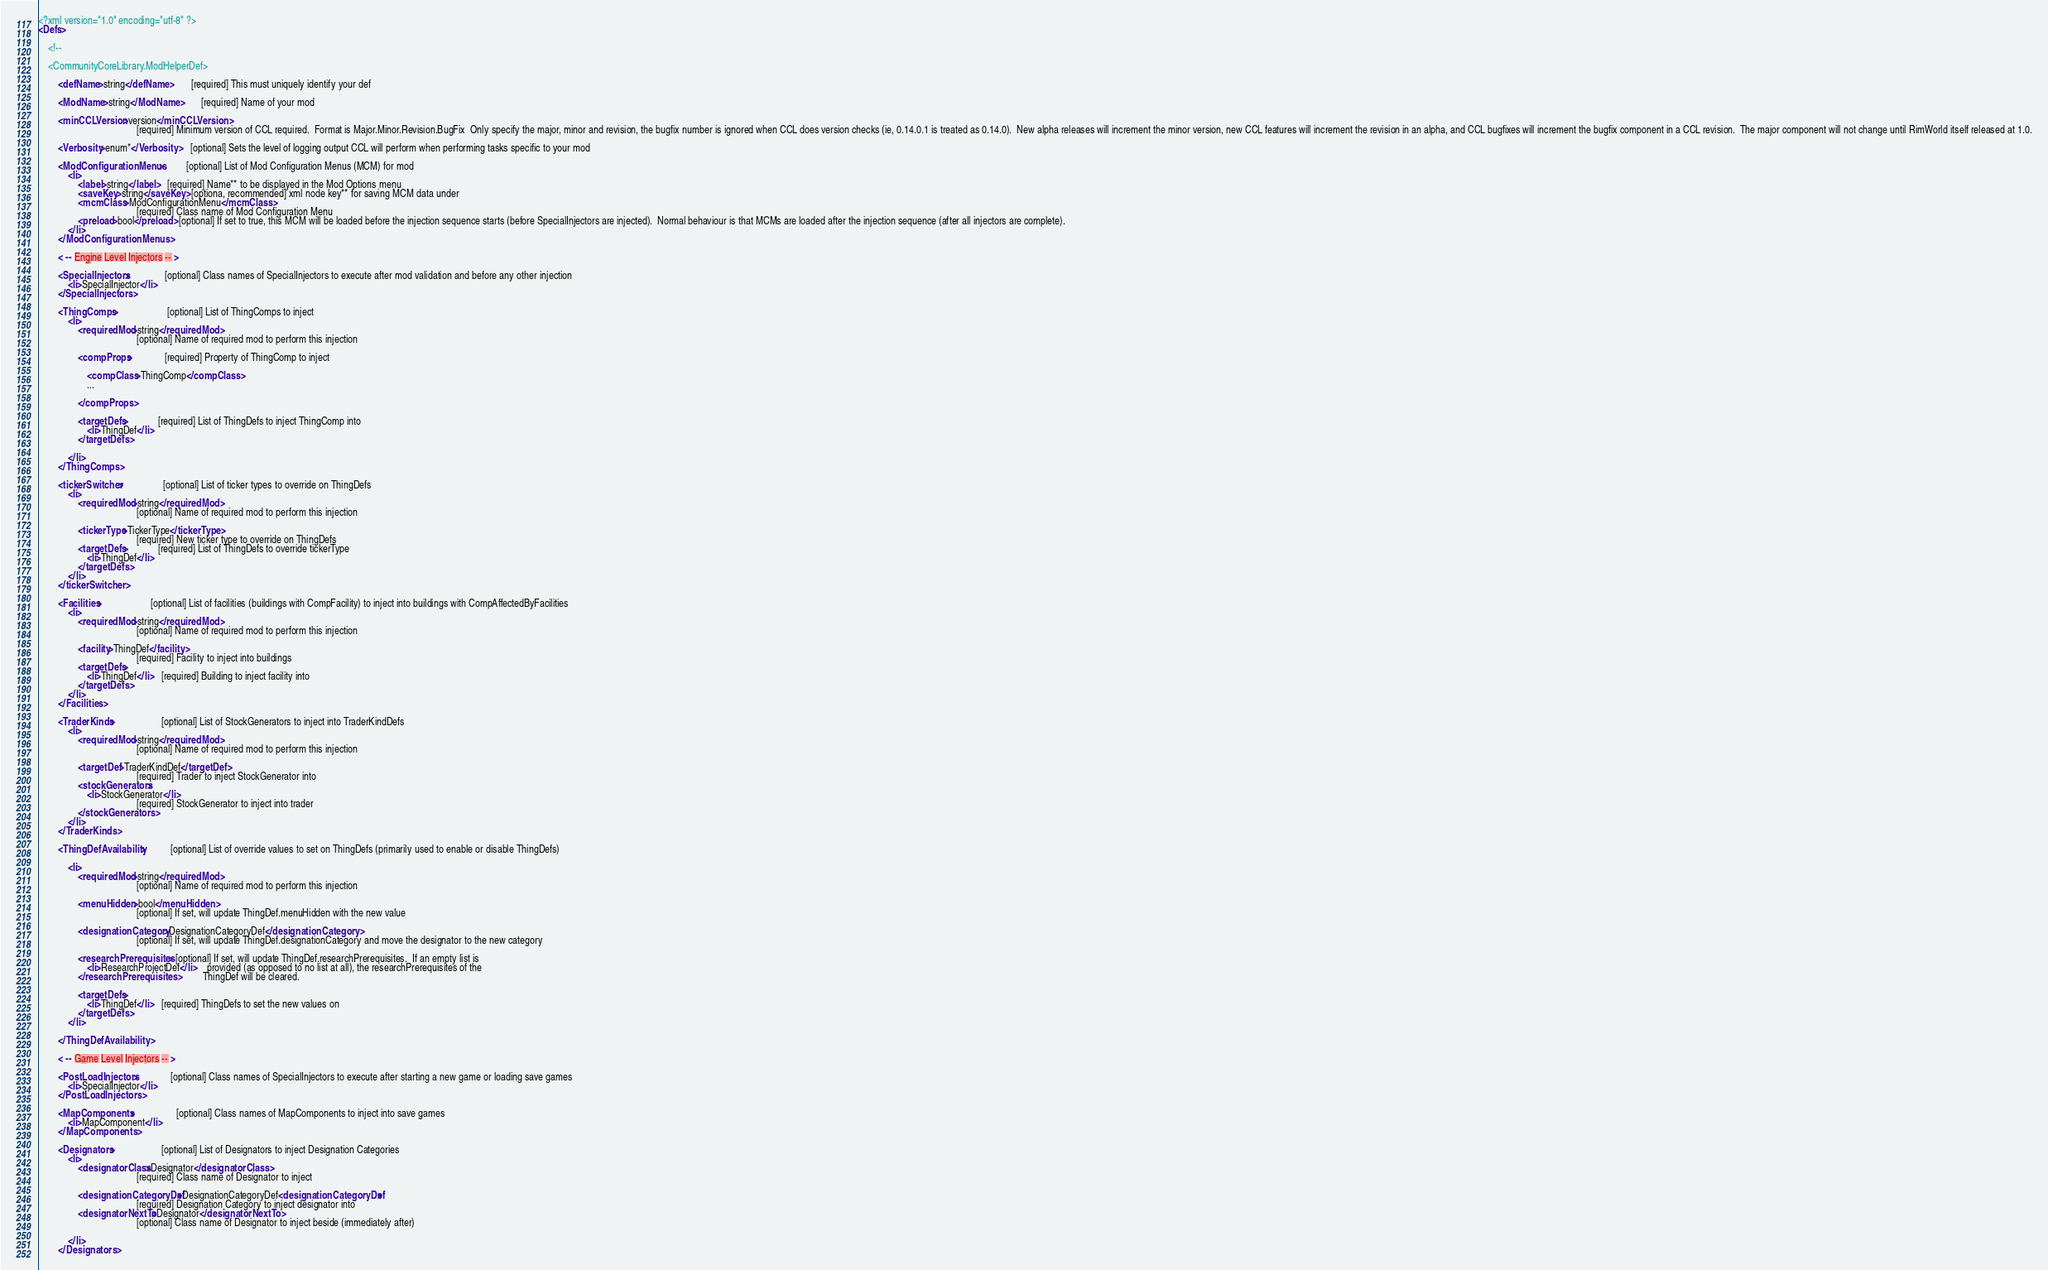<code> <loc_0><loc_0><loc_500><loc_500><_XML_><?xml version="1.0" encoding="utf-8" ?>
<Defs>

    <!--

    <CommunityCoreLibrary.ModHelperDef>

        <defName>string</defName>       [required] This must uniquely identify your def

        <ModName>string</ModName>       [required] Name of your mod

        <minCCLVersion>version</minCCLVersion>
                                        [required] Minimum version of CCL required.  Format is Major.Minor.Revision.BugFix  Only specify the major, minor and revision, the bugfix number is ignored when CCL does version checks (ie, 0.14.0.1 is treated as 0.14.0).  New alpha releases will increment the minor version, new CCL features will increment the revision in an alpha, and CCL bugfixes will increment the bugfix component in a CCL revision.  The major component will not change until RimWorld itself released at 1.0.

        <Verbosity>enum*</Verbosity>    [optional] Sets the level of logging output CCL will perform when performing tasks specific to your mod

        <ModConfigurationMenus>         [optional] List of Mod Configuration Menus (MCM) for mod
            <li>
                <label>string</label>   [required] Name** to be displayed in the Mod Options menu
                <saveKey>string</saveKey> [optiona, recommended] xml node key** for saving MCM data under
                <mcmClass>ModConfigurationMenu</mcmClass>
                                        [required] Class name of Mod Configuration Menu
                <preload>bool</preload> [optional] If set to true, this MCM will be loaded before the injection sequence starts (before SpecialInjectors are injected).  Normal behaviour is that MCMs are loaded after the injection sequence (after all injectors are complete).
            </li>
        </ModConfigurationMenus>

        < -- Engine Level Injectors -- >

        <SpecialInjectors>              [optional] Class names of SpecialInjectors to execute after mod validation and before any other injection
            <li>SpecialInjector</li>
        </SpecialInjectors>

        <ThingComps>                    [optional] List of ThingComps to inject
            <li>
                <requiredMod>string</requiredMod>
                                        [optional] Name of required mod to perform this injection

                <compProps>             [required] Property of ThingComp to inject

                    <compClass>ThingComp</compClass>
                    ...

                </compProps>

                <targetDefs>            [required] List of ThingDefs to inject ThingComp into
                    <li>ThingDef</li>
                </targetDefs>

            </li>
        </ThingComps>

        <tickerSwitcher>                [optional] List of ticker types to override on ThingDefs
            <li>
                <requiredMod>string</requiredMod>
                                        [optional] Name of required mod to perform this injection

                <tickerType>TickerType</tickerType>
                                        [required] New ticker type to override on ThingDefs
                <targetDefs>            [required] List of ThingDefs to override tickerType
                    <li>ThingDef</li>
                </targetDefs>
            </li>
        </tickerSwitcher>

        <Facilities>                    [optional] List of facilities (buildings with CompFacility) to inject into buildings with CompAffectedByFacilities
            <li>
                <requiredMod>string</requiredMod>
                                        [optional] Name of required mod to perform this injection

                <facility>ThingDef</facility>
                                        [required] Facility to inject into buildings
                <targetDefs>
                    <li>ThingDef</li>   [required] Building to inject facility into
                </targetDefs>
            </li>
        </Facilities>

        <TraderKinds>                   [optional] List of StockGenerators to inject into TraderKindDefs
            <li>
                <requiredMod>string</requiredMod>
                                        [optional] Name of required mod to perform this injection
                                        
                <targetDef>TraderKindDef</targetDef>
                                        [required] Trader to inject StockGenerator into
                <stockGenerators>
                    <li>StockGenerator</li>
                                        [required] StockGenerator to inject into trader
                </stockGenerators>
            </li>
        </TraderKinds>

        <ThingDefAvailability>          [optional] List of override values to set on ThingDefs (primarily used to enable or disable ThingDefs)

            <li>
                <requiredMod>string</requiredMod>
                                        [optional] Name of required mod to perform this injection
                                        
                <menuHidden>bool</menuHidden>
                                        [optional] If set, will update ThingDef.menuHidden with the new value
                                        
                <designationCategory>DesignationCategoryDef</designationCategory>
                                        [optional] If set, will update ThingDef.designationCategory and move the designator to the new category

                <researchPrerequisites> [optional] If set, will update ThingDef.researchPrerequisites.  If an empty list is
                    <li>ResearchProjectDef</li>    provided (as opposed to no list at all), the researchPrerequisites of the
                </researchPrerequisites>           ThingDef will be cleared.

                <targetDefs>
                    <li>ThingDef</li>   [required] ThingDefs to set the new values on
                </targetDefs>
            </li>

        </ThingDefAvailability>

        < -- Game Level Injectors -- >

        <PostLoadInjectors>             [optional] Class names of SpecialInjectors to execute after starting a new game or loading save games
            <li>SpecialInjector</li>
        </PostLoadInjectors>

        <MapComponents>                 [optional] Class names of MapComponents to inject into save games
            <li>MapComponent</li>
        </MapComponents>

        <Designators>                   [optional] List of Designators to inject Designation Categories
            <li>
                <designatorClass>Designator</designatorClass>
                                        [required] Class name of Designator to inject

                <designationCategoryDef>DesignationCategoryDef<designationCategoryDef>
                                        [required] Designation Category to inject designator into
                <designatorNextTo>Designator</designatorNextTo>
                                        [optional] Class name of Designator to inject beside (immediately after)

            </li>
        </Designators>
</code> 